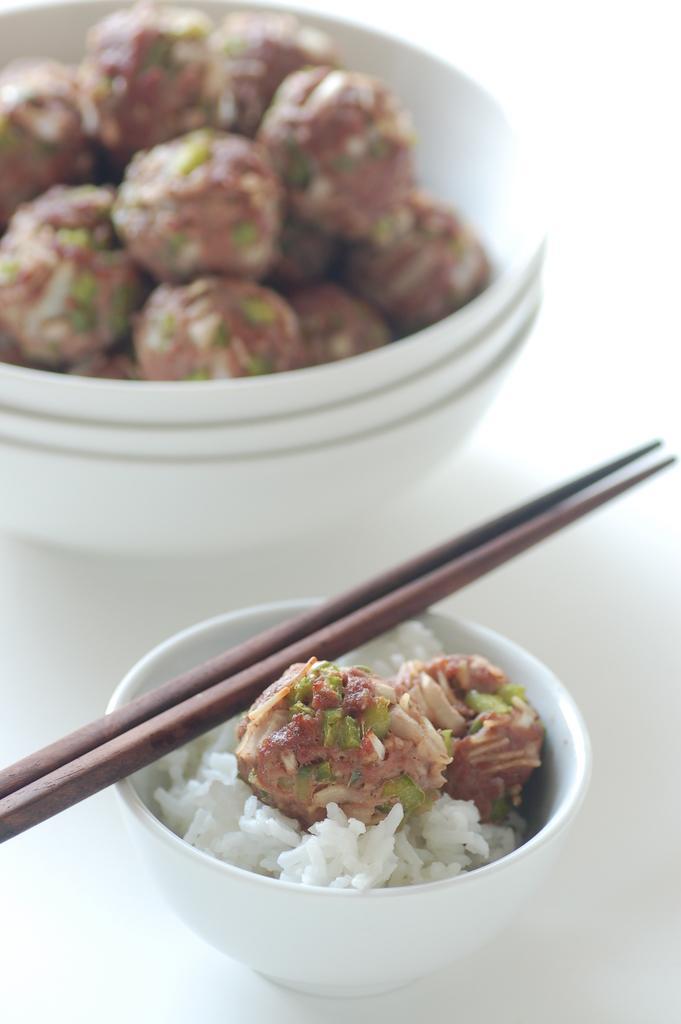Could you give a brief overview of what you see in this image? There is a bowl. There is rice and laddu on a bowl. There is a stick on a bowl. 